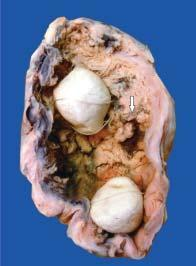re lassification of chromosomes also present in the lumen?
Answer the question using a single word or phrase. No 